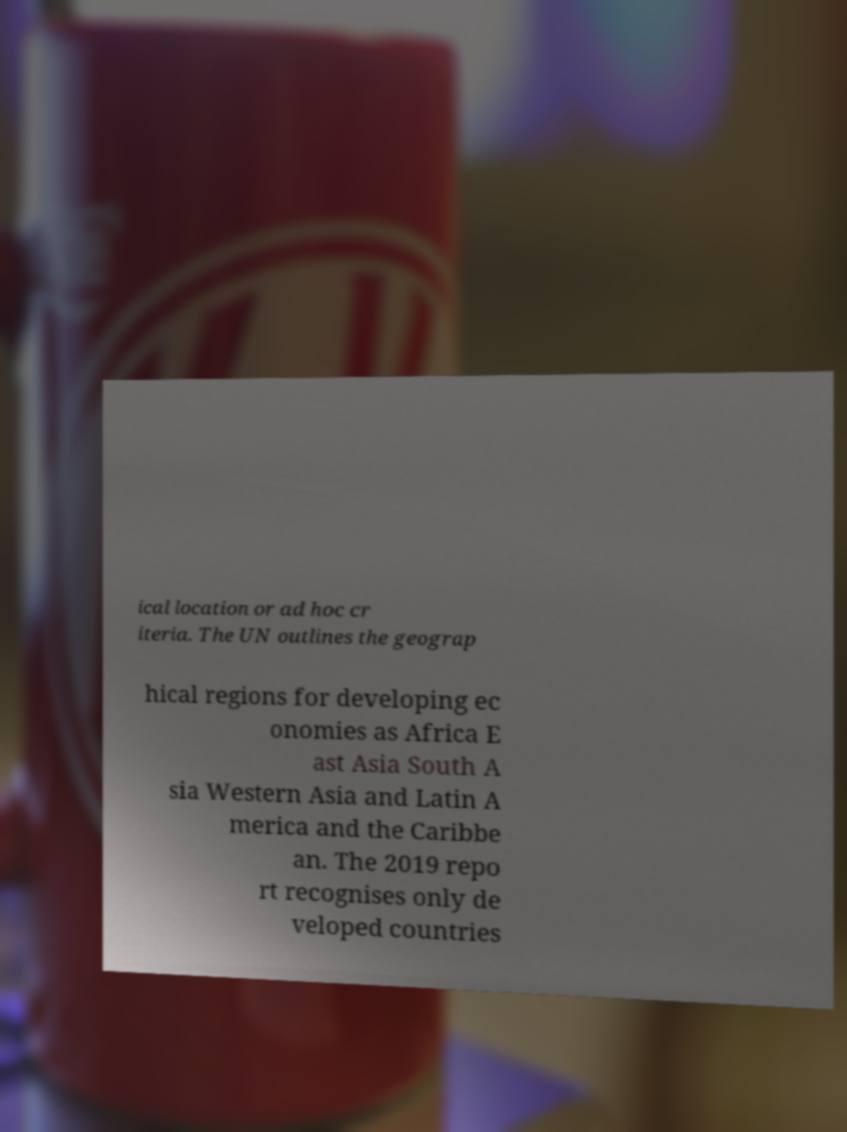Can you read and provide the text displayed in the image?This photo seems to have some interesting text. Can you extract and type it out for me? ical location or ad hoc cr iteria. The UN outlines the geograp hical regions for developing ec onomies as Africa E ast Asia South A sia Western Asia and Latin A merica and the Caribbe an. The 2019 repo rt recognises only de veloped countries 